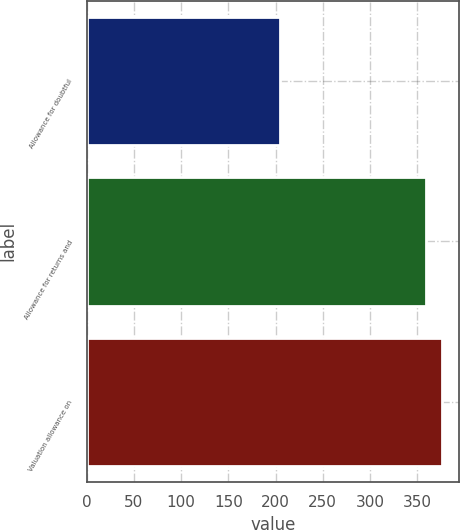Convert chart to OTSL. <chart><loc_0><loc_0><loc_500><loc_500><bar_chart><fcel>Allowance for doubtful<fcel>Allowance for returns and<fcel>Valuation allowance on<nl><fcel>205<fcel>359<fcel>376<nl></chart> 